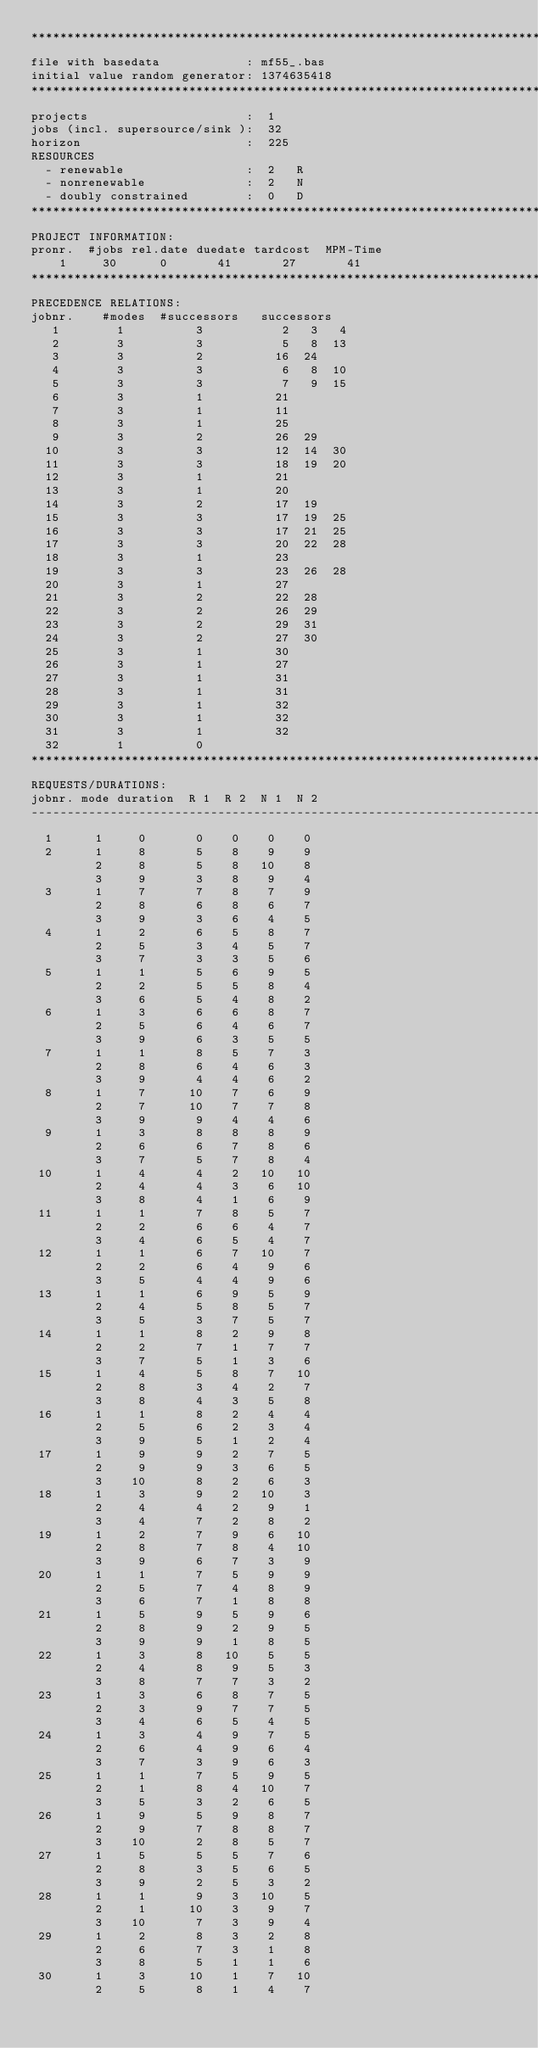Convert code to text. <code><loc_0><loc_0><loc_500><loc_500><_ObjectiveC_>************************************************************************
file with basedata            : mf55_.bas
initial value random generator: 1374635418
************************************************************************
projects                      :  1
jobs (incl. supersource/sink ):  32
horizon                       :  225
RESOURCES
  - renewable                 :  2   R
  - nonrenewable              :  2   N
  - doubly constrained        :  0   D
************************************************************************
PROJECT INFORMATION:
pronr.  #jobs rel.date duedate tardcost  MPM-Time
    1     30      0       41       27       41
************************************************************************
PRECEDENCE RELATIONS:
jobnr.    #modes  #successors   successors
   1        1          3           2   3   4
   2        3          3           5   8  13
   3        3          2          16  24
   4        3          3           6   8  10
   5        3          3           7   9  15
   6        3          1          21
   7        3          1          11
   8        3          1          25
   9        3          2          26  29
  10        3          3          12  14  30
  11        3          3          18  19  20
  12        3          1          21
  13        3          1          20
  14        3          2          17  19
  15        3          3          17  19  25
  16        3          3          17  21  25
  17        3          3          20  22  28
  18        3          1          23
  19        3          3          23  26  28
  20        3          1          27
  21        3          2          22  28
  22        3          2          26  29
  23        3          2          29  31
  24        3          2          27  30
  25        3          1          30
  26        3          1          27
  27        3          1          31
  28        3          1          31
  29        3          1          32
  30        3          1          32
  31        3          1          32
  32        1          0        
************************************************************************
REQUESTS/DURATIONS:
jobnr. mode duration  R 1  R 2  N 1  N 2
------------------------------------------------------------------------
  1      1     0       0    0    0    0
  2      1     8       5    8    9    9
         2     8       5    8   10    8
         3     9       3    8    9    4
  3      1     7       7    8    7    9
         2     8       6    8    6    7
         3     9       3    6    4    5
  4      1     2       6    5    8    7
         2     5       3    4    5    7
         3     7       3    3    5    6
  5      1     1       5    6    9    5
         2     2       5    5    8    4
         3     6       5    4    8    2
  6      1     3       6    6    8    7
         2     5       6    4    6    7
         3     9       6    3    5    5
  7      1     1       8    5    7    3
         2     8       6    4    6    3
         3     9       4    4    6    2
  8      1     7      10    7    6    9
         2     7      10    7    7    8
         3     9       9    4    4    6
  9      1     3       8    8    8    9
         2     6       6    7    8    6
         3     7       5    7    8    4
 10      1     4       4    2   10   10
         2     4       4    3    6   10
         3     8       4    1    6    9
 11      1     1       7    8    5    7
         2     2       6    6    4    7
         3     4       6    5    4    7
 12      1     1       6    7   10    7
         2     2       6    4    9    6
         3     5       4    4    9    6
 13      1     1       6    9    5    9
         2     4       5    8    5    7
         3     5       3    7    5    7
 14      1     1       8    2    9    8
         2     2       7    1    7    7
         3     7       5    1    3    6
 15      1     4       5    8    7   10
         2     8       3    4    2    7
         3     8       4    3    5    8
 16      1     1       8    2    4    4
         2     5       6    2    3    4
         3     9       5    1    2    4
 17      1     9       9    2    7    5
         2     9       9    3    6    5
         3    10       8    2    6    3
 18      1     3       9    2   10    3
         2     4       4    2    9    1
         3     4       7    2    8    2
 19      1     2       7    9    6   10
         2     8       7    8    4   10
         3     9       6    7    3    9
 20      1     1       7    5    9    9
         2     5       7    4    8    9
         3     6       7    1    8    8
 21      1     5       9    5    9    6
         2     8       9    2    9    5
         3     9       9    1    8    5
 22      1     3       8   10    5    5
         2     4       8    9    5    3
         3     8       7    7    3    2
 23      1     3       6    8    7    5
         2     3       9    7    7    5
         3     4       6    5    4    5
 24      1     3       4    9    7    5
         2     6       4    9    6    4
         3     7       3    9    6    3
 25      1     1       7    5    9    5
         2     1       8    4   10    7
         3     5       3    2    6    5
 26      1     9       5    9    8    7
         2     9       7    8    8    7
         3    10       2    8    5    7
 27      1     5       5    5    7    6
         2     8       3    5    6    5
         3     9       2    5    3    2
 28      1     1       9    3   10    5
         2     1      10    3    9    7
         3    10       7    3    9    4
 29      1     2       8    3    2    8
         2     6       7    3    1    8
         3     8       5    1    1    6
 30      1     3      10    1    7   10
         2     5       8    1    4    7</code> 